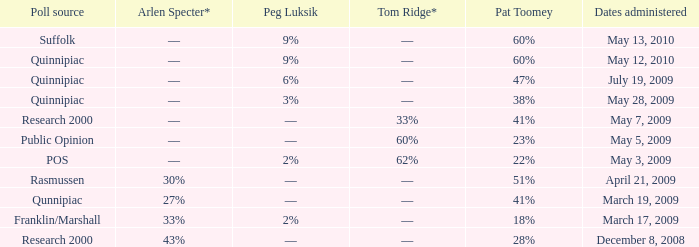Which Poll source has Pat Toomey of 23%? Public Opinion. 